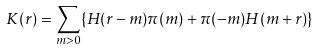Convert formula to latex. <formula><loc_0><loc_0><loc_500><loc_500>K ( r ) = \sum _ { m > 0 } \{ H ( r - m ) \pi ( m ) + \pi ( - m ) H ( m + r ) \}</formula> 